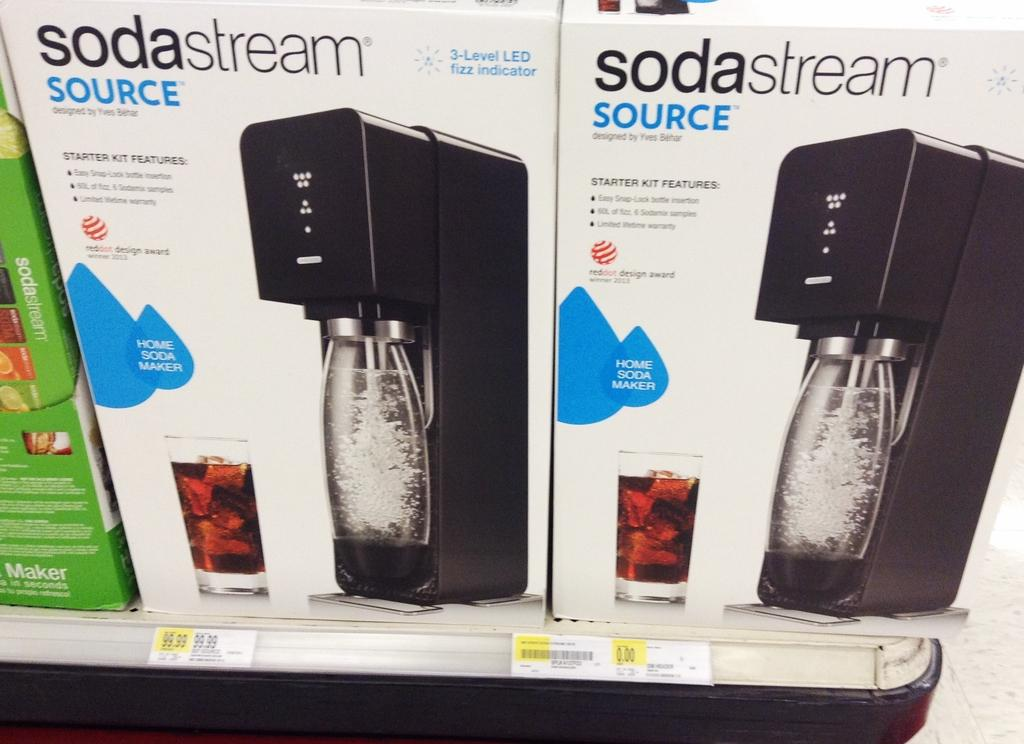How many boxes are in the image? There are 3 boxes in the image. What can be found on the boxes? There is writing on the boxes. How many glasses are depicted in the image? There are 2 glasses depicted in the image. How many machines are depicted in the image? There are 2 machines depicted in the image. How many jars are depicted in the image? There are 2 jars depicted in the image. Are there any price tags visible in the image? Yes, price tags are visible in the image. Can you tell me how many toes are visible on the power cord in the image? There is no power cord or toes present in the image. What type of impulse can be seen affecting the jars in the image? There is no impulse affecting the jars in the image; they are stationary. 